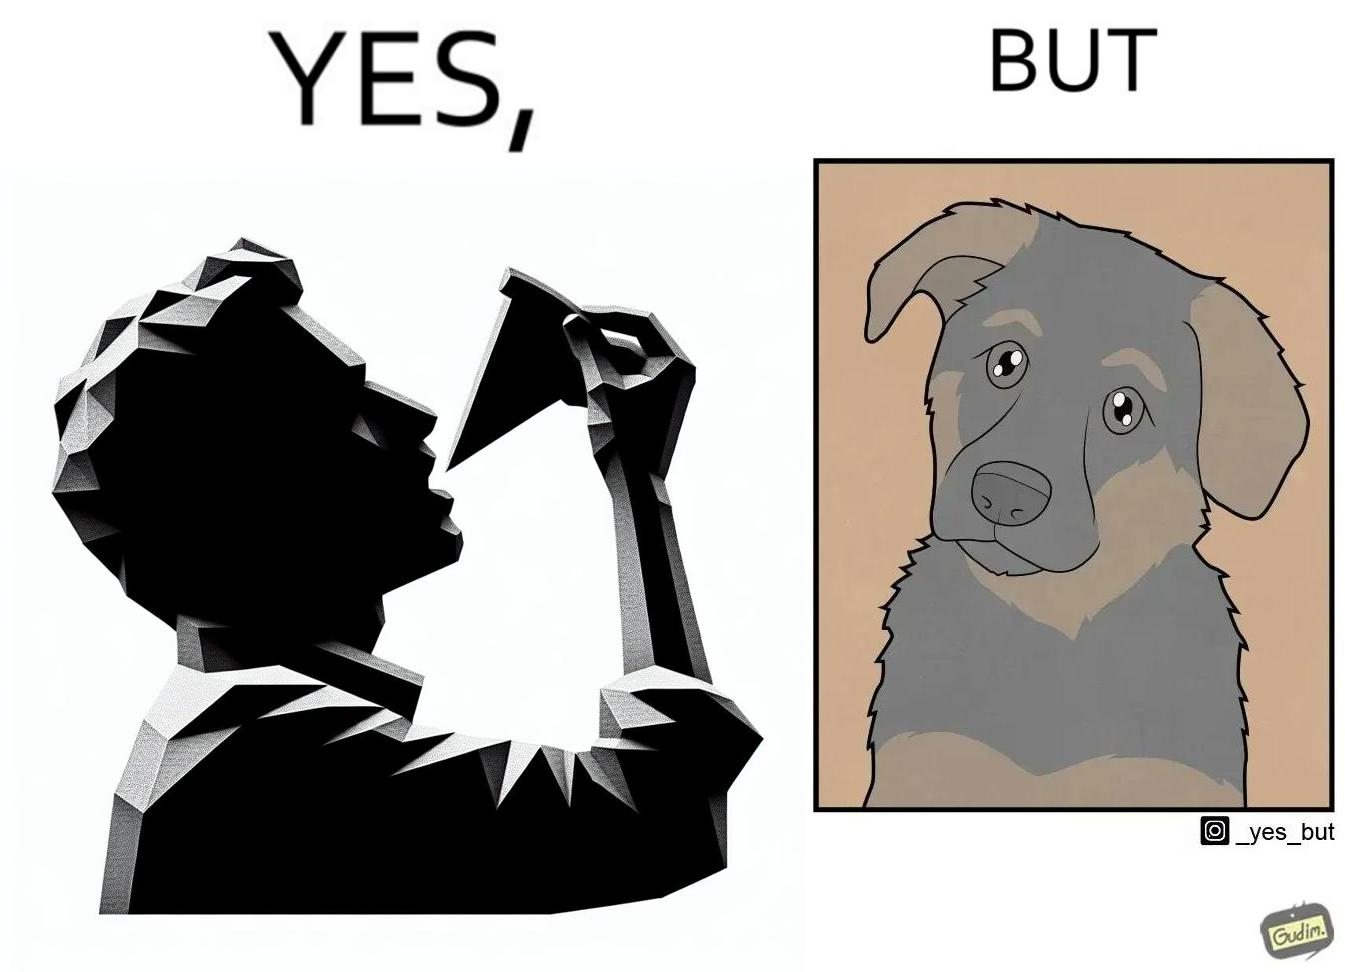What is shown in this image? The images are funny since they show how pet owners cannot enjoy any tasty food like pizza without sharing with their pets. The look from the pets makes the owner too guilty if he does not share his food 